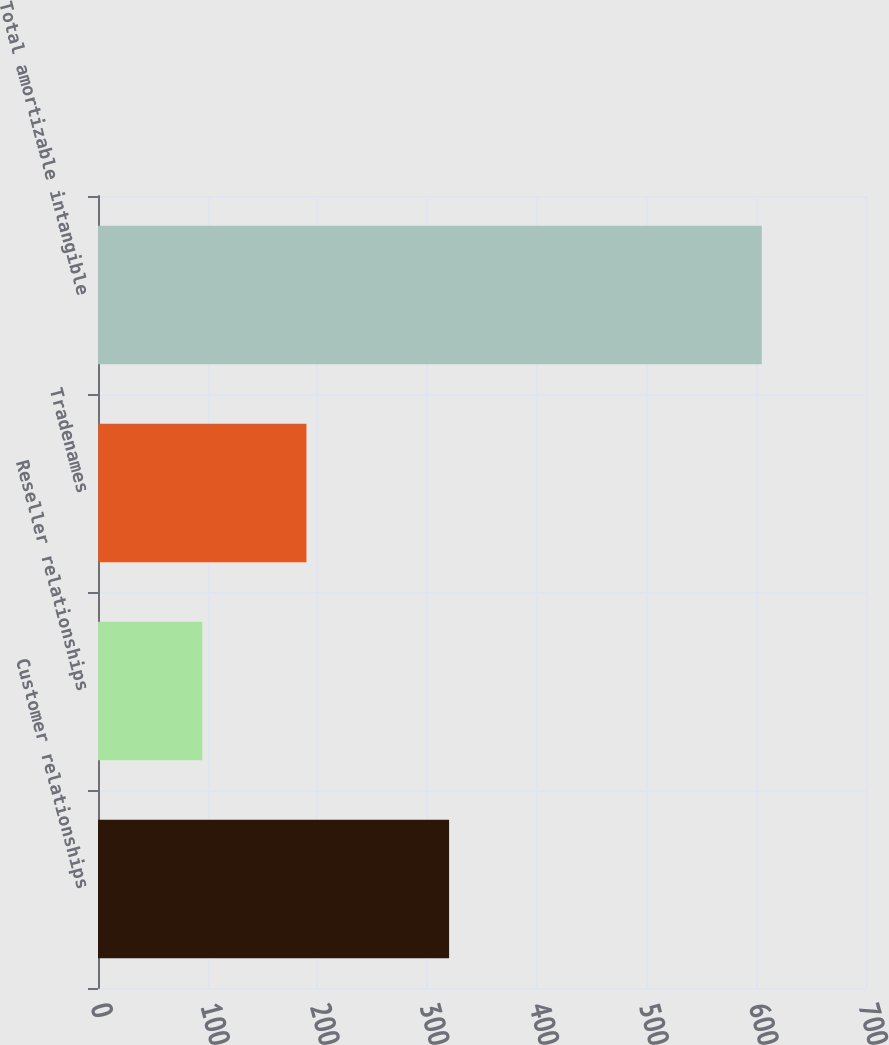Convert chart. <chart><loc_0><loc_0><loc_500><loc_500><bar_chart><fcel>Customer relationships<fcel>Reseller relationships<fcel>Tradenames<fcel>Total amortizable intangible<nl><fcel>320<fcel>95<fcel>190<fcel>605<nl></chart> 